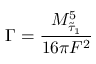<formula> <loc_0><loc_0><loc_500><loc_500>\Gamma = \frac { M _ { \tilde { \tau } _ { 1 } } ^ { 5 } } { 1 6 \pi F ^ { 2 } } \,</formula> 